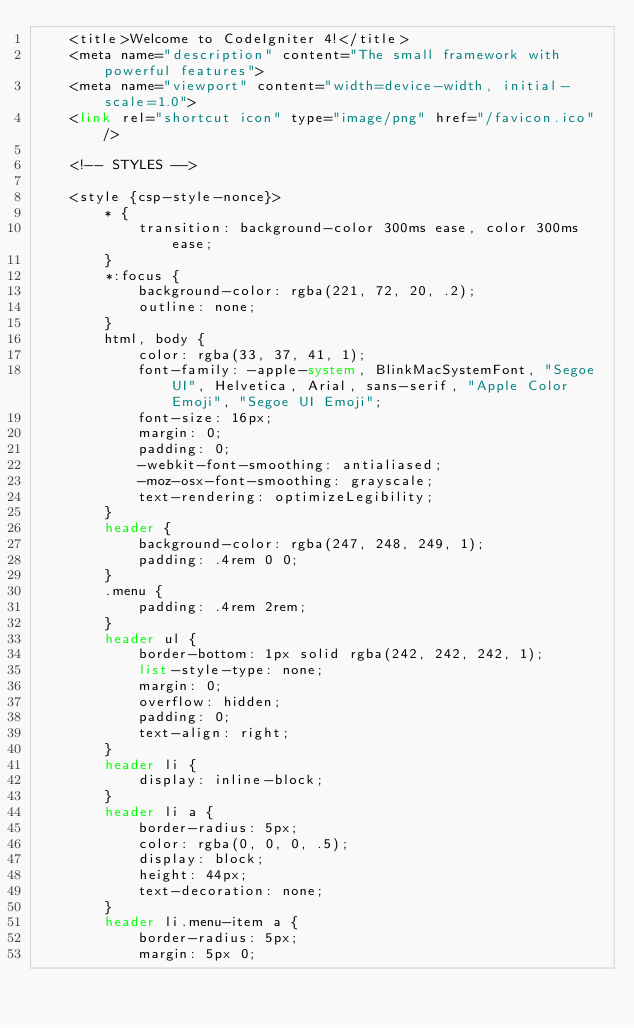Convert code to text. <code><loc_0><loc_0><loc_500><loc_500><_PHP_>	<title>Welcome to CodeIgniter 4!</title>
	<meta name="description" content="The small framework with powerful features">
	<meta name="viewport" content="width=device-width, initial-scale=1.0">
	<link rel="shortcut icon" type="image/png" href="/favicon.ico"/>

	<!-- STYLES -->

	<style {csp-style-nonce}>
		* {
			transition: background-color 300ms ease, color 300ms ease;
		}
		*:focus {
			background-color: rgba(221, 72, 20, .2);
			outline: none;
		}
		html, body {
			color: rgba(33, 37, 41, 1);
			font-family: -apple-system, BlinkMacSystemFont, "Segoe UI", Helvetica, Arial, sans-serif, "Apple Color Emoji", "Segoe UI Emoji";
			font-size: 16px;
			margin: 0;
			padding: 0;
			-webkit-font-smoothing: antialiased;
			-moz-osx-font-smoothing: grayscale;
			text-rendering: optimizeLegibility;
		}
		header {
			background-color: rgba(247, 248, 249, 1);
			padding: .4rem 0 0;
		}
		.menu {
			padding: .4rem 2rem;
		}
		header ul {
			border-bottom: 1px solid rgba(242, 242, 242, 1);
			list-style-type: none;
			margin: 0;
			overflow: hidden;
			padding: 0;
			text-align: right;
		}
		header li {
			display: inline-block;
		}
		header li a {
			border-radius: 5px;
			color: rgba(0, 0, 0, .5);
			display: block;
			height: 44px;
			text-decoration: none;
		}
		header li.menu-item a {
			border-radius: 5px;
			margin: 5px 0;</code> 